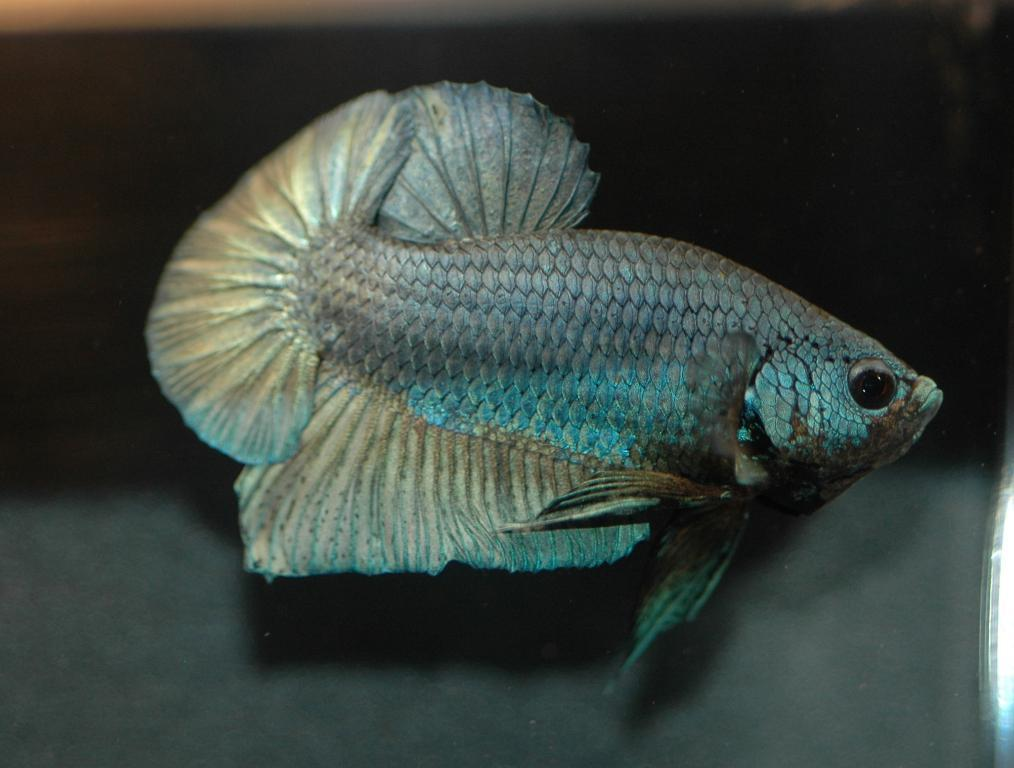What type of animal is in the image? There is a fish in the image. What colors can be seen on the fish? The fish has blue, black, black, and green colors. What color is the background of the image? The background of the image is black. What type of gate is depicted in the image? There is no gate present in the image; it features a fish with blue, black, and green colors against a black background. 